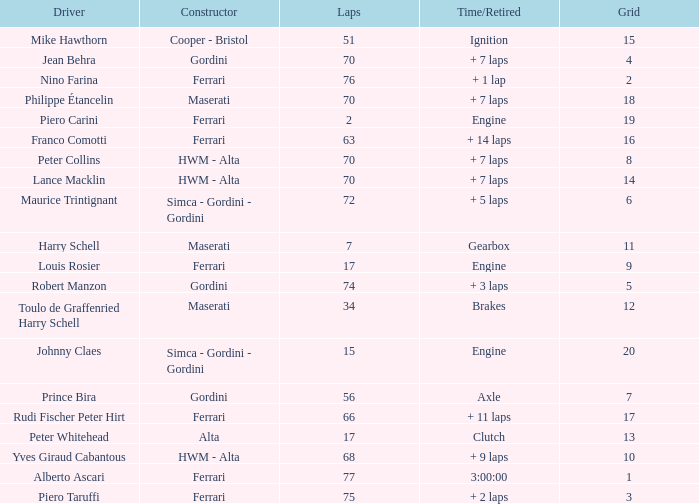Can you give me this table as a dict? {'header': ['Driver', 'Constructor', 'Laps', 'Time/Retired', 'Grid'], 'rows': [['Mike Hawthorn', 'Cooper - Bristol', '51', 'Ignition', '15'], ['Jean Behra', 'Gordini', '70', '+ 7 laps', '4'], ['Nino Farina', 'Ferrari', '76', '+ 1 lap', '2'], ['Philippe Étancelin', 'Maserati', '70', '+ 7 laps', '18'], ['Piero Carini', 'Ferrari', '2', 'Engine', '19'], ['Franco Comotti', 'Ferrari', '63', '+ 14 laps', '16'], ['Peter Collins', 'HWM - Alta', '70', '+ 7 laps', '8'], ['Lance Macklin', 'HWM - Alta', '70', '+ 7 laps', '14'], ['Maurice Trintignant', 'Simca - Gordini - Gordini', '72', '+ 5 laps', '6'], ['Harry Schell', 'Maserati', '7', 'Gearbox', '11'], ['Louis Rosier', 'Ferrari', '17', 'Engine', '9'], ['Robert Manzon', 'Gordini', '74', '+ 3 laps', '5'], ['Toulo de Graffenried Harry Schell', 'Maserati', '34', 'Brakes', '12'], ['Johnny Claes', 'Simca - Gordini - Gordini', '15', 'Engine', '20'], ['Prince Bira', 'Gordini', '56', 'Axle', '7'], ['Rudi Fischer Peter Hirt', 'Ferrari', '66', '+ 11 laps', '17'], ['Peter Whitehead', 'Alta', '17', 'Clutch', '13'], ['Yves Giraud Cabantous', 'HWM - Alta', '68', '+ 9 laps', '10'], ['Alberto Ascari', 'Ferrari', '77', '3:00:00', '1'], ['Piero Taruffi', 'Ferrari', '75', '+ 2 laps', '3']]} Who drove the car with over 66 laps with a grid of 5? Robert Manzon. 